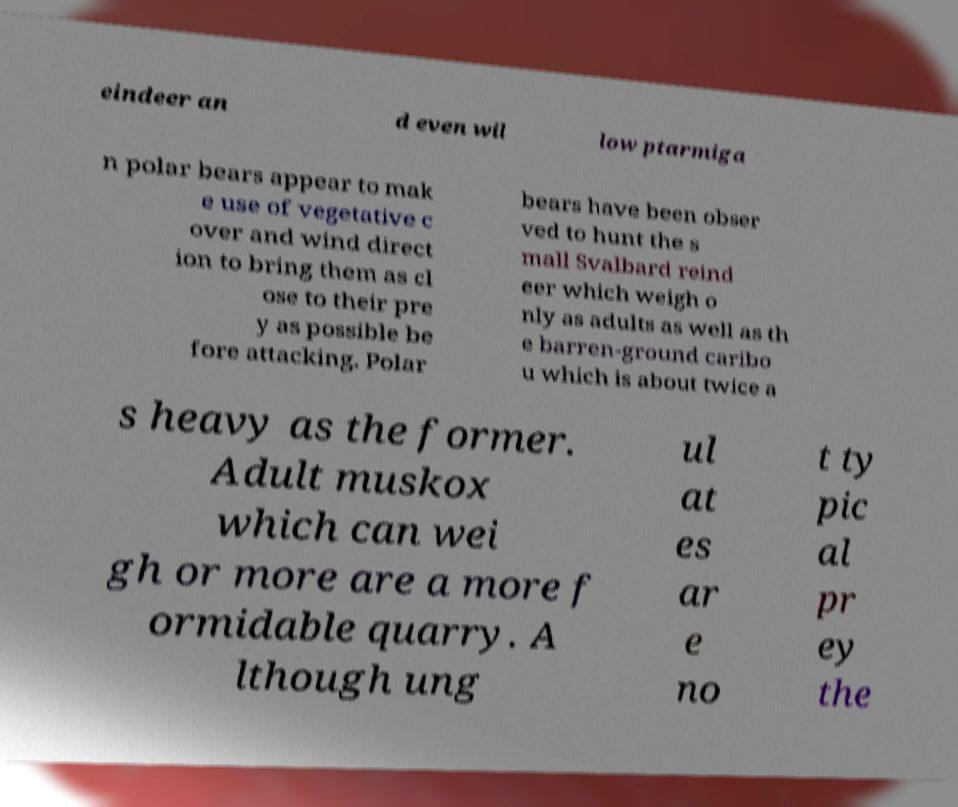I need the written content from this picture converted into text. Can you do that? eindeer an d even wil low ptarmiga n polar bears appear to mak e use of vegetative c over and wind direct ion to bring them as cl ose to their pre y as possible be fore attacking. Polar bears have been obser ved to hunt the s mall Svalbard reind eer which weigh o nly as adults as well as th e barren-ground caribo u which is about twice a s heavy as the former. Adult muskox which can wei gh or more are a more f ormidable quarry. A lthough ung ul at es ar e no t ty pic al pr ey the 